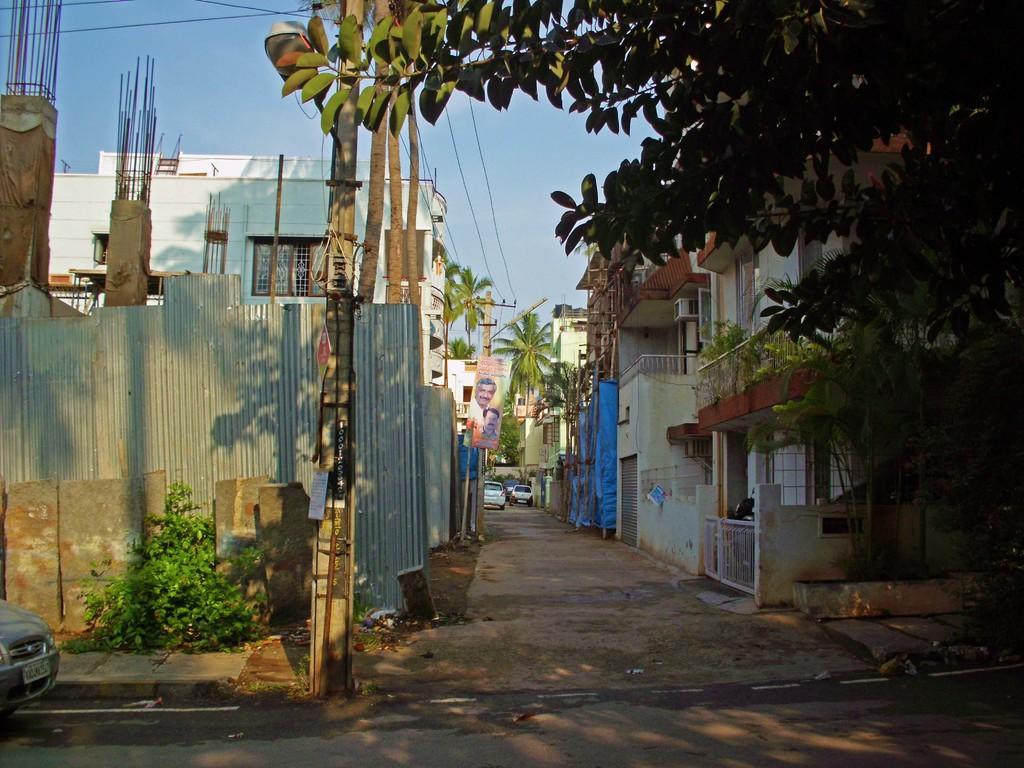In one or two sentences, can you explain what this image depicts? In this aimeg, we can see buildings, trees, poles, banner, walkway, road, vehicles, plants trees, railings, grill, windows, pillars, wires and few objects. Background we can see the sky. On the left side bottom of the image, we can see a vehicle on the road. 